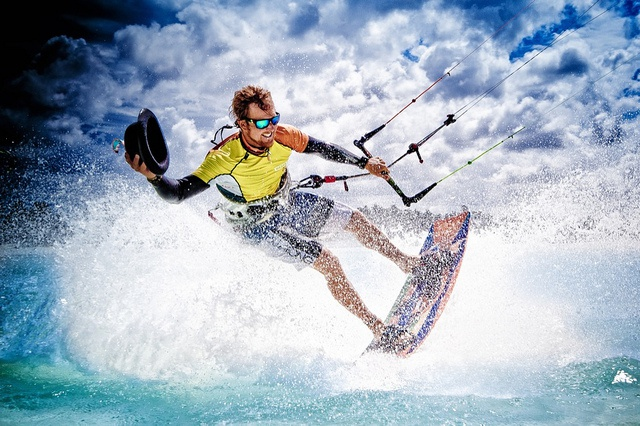Describe the objects in this image and their specific colors. I can see people in black, lightgray, darkgray, and gray tones and surfboard in black, lightgray, darkgray, lightpink, and gray tones in this image. 